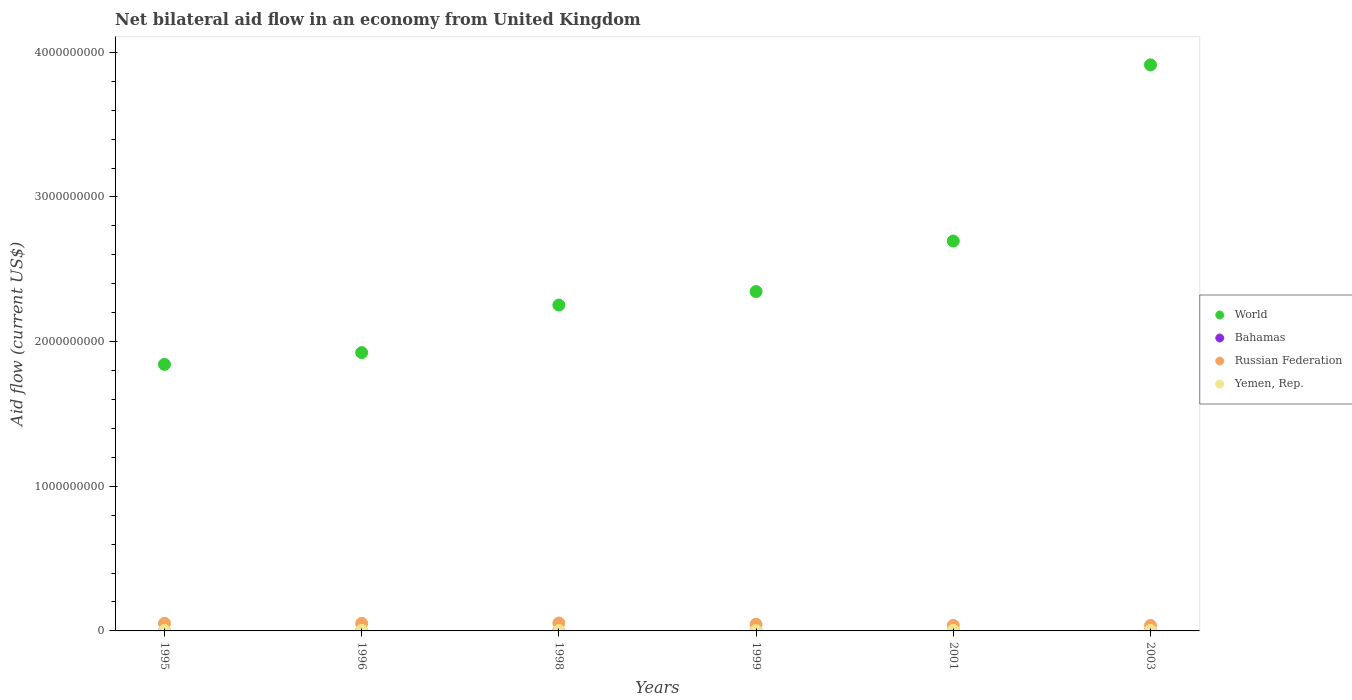How many different coloured dotlines are there?
Offer a very short reply. 4. What is the net bilateral aid flow in World in 1996?
Keep it short and to the point. 1.92e+09. Across all years, what is the maximum net bilateral aid flow in World?
Offer a terse response. 3.91e+09. Across all years, what is the minimum net bilateral aid flow in Yemen, Rep.?
Provide a short and direct response. 1.76e+06. In which year was the net bilateral aid flow in Russian Federation maximum?
Offer a terse response. 1998. In which year was the net bilateral aid flow in World minimum?
Provide a short and direct response. 1995. What is the total net bilateral aid flow in Yemen, Rep. in the graph?
Offer a terse response. 1.59e+07. What is the difference between the net bilateral aid flow in Russian Federation in 1996 and that in 1999?
Offer a very short reply. 5.66e+06. What is the difference between the net bilateral aid flow in Bahamas in 2003 and the net bilateral aid flow in Russian Federation in 1999?
Keep it short and to the point. -4.62e+07. What is the average net bilateral aid flow in Yemen, Rep. per year?
Offer a very short reply. 2.65e+06. In the year 1996, what is the difference between the net bilateral aid flow in World and net bilateral aid flow in Yemen, Rep.?
Offer a terse response. 1.92e+09. What is the ratio of the net bilateral aid flow in Yemen, Rep. in 1996 to that in 2003?
Your answer should be very brief. 1.17. What is the difference between the highest and the second highest net bilateral aid flow in World?
Offer a very short reply. 1.22e+09. In how many years, is the net bilateral aid flow in Yemen, Rep. greater than the average net bilateral aid flow in Yemen, Rep. taken over all years?
Your answer should be compact. 3. Is it the case that in every year, the sum of the net bilateral aid flow in Russian Federation and net bilateral aid flow in Yemen, Rep.  is greater than the sum of net bilateral aid flow in Bahamas and net bilateral aid flow in World?
Your answer should be very brief. Yes. Is it the case that in every year, the sum of the net bilateral aid flow in World and net bilateral aid flow in Bahamas  is greater than the net bilateral aid flow in Yemen, Rep.?
Ensure brevity in your answer.  Yes. Does the net bilateral aid flow in Yemen, Rep. monotonically increase over the years?
Your response must be concise. No. Is the net bilateral aid flow in Bahamas strictly less than the net bilateral aid flow in Russian Federation over the years?
Give a very brief answer. Yes. How many dotlines are there?
Provide a succinct answer. 4. Where does the legend appear in the graph?
Provide a short and direct response. Center right. How are the legend labels stacked?
Offer a terse response. Vertical. What is the title of the graph?
Give a very brief answer. Net bilateral aid flow in an economy from United Kingdom. What is the label or title of the Y-axis?
Make the answer very short. Aid flow (current US$). What is the Aid flow (current US$) of World in 1995?
Give a very brief answer. 1.84e+09. What is the Aid flow (current US$) of Bahamas in 1995?
Ensure brevity in your answer.  7.00e+04. What is the Aid flow (current US$) in Russian Federation in 1995?
Give a very brief answer. 5.23e+07. What is the Aid flow (current US$) in Yemen, Rep. in 1995?
Keep it short and to the point. 2.44e+06. What is the Aid flow (current US$) of World in 1996?
Ensure brevity in your answer.  1.92e+09. What is the Aid flow (current US$) of Russian Federation in 1996?
Make the answer very short. 5.18e+07. What is the Aid flow (current US$) of Yemen, Rep. in 1996?
Offer a terse response. 3.36e+06. What is the Aid flow (current US$) of World in 1998?
Give a very brief answer. 2.25e+09. What is the Aid flow (current US$) in Russian Federation in 1998?
Give a very brief answer. 5.48e+07. What is the Aid flow (current US$) in Yemen, Rep. in 1998?
Keep it short and to the point. 2.13e+06. What is the Aid flow (current US$) of World in 1999?
Your answer should be very brief. 2.35e+09. What is the Aid flow (current US$) of Bahamas in 1999?
Make the answer very short. 3.00e+04. What is the Aid flow (current US$) in Russian Federation in 1999?
Provide a short and direct response. 4.62e+07. What is the Aid flow (current US$) in Yemen, Rep. in 1999?
Offer a terse response. 1.76e+06. What is the Aid flow (current US$) in World in 2001?
Make the answer very short. 2.70e+09. What is the Aid flow (current US$) in Bahamas in 2001?
Your answer should be very brief. 4.00e+04. What is the Aid flow (current US$) of Russian Federation in 2001?
Give a very brief answer. 3.83e+07. What is the Aid flow (current US$) in Yemen, Rep. in 2001?
Offer a terse response. 3.33e+06. What is the Aid flow (current US$) of World in 2003?
Provide a short and direct response. 3.91e+09. What is the Aid flow (current US$) in Bahamas in 2003?
Your answer should be very brief. 2.00e+04. What is the Aid flow (current US$) in Russian Federation in 2003?
Offer a very short reply. 3.79e+07. What is the Aid flow (current US$) in Yemen, Rep. in 2003?
Provide a succinct answer. 2.87e+06. Across all years, what is the maximum Aid flow (current US$) of World?
Offer a very short reply. 3.91e+09. Across all years, what is the maximum Aid flow (current US$) in Bahamas?
Your response must be concise. 1.60e+05. Across all years, what is the maximum Aid flow (current US$) of Russian Federation?
Give a very brief answer. 5.48e+07. Across all years, what is the maximum Aid flow (current US$) in Yemen, Rep.?
Provide a short and direct response. 3.36e+06. Across all years, what is the minimum Aid flow (current US$) of World?
Give a very brief answer. 1.84e+09. Across all years, what is the minimum Aid flow (current US$) in Bahamas?
Give a very brief answer. 2.00e+04. Across all years, what is the minimum Aid flow (current US$) of Russian Federation?
Your answer should be compact. 3.79e+07. Across all years, what is the minimum Aid flow (current US$) of Yemen, Rep.?
Offer a terse response. 1.76e+06. What is the total Aid flow (current US$) of World in the graph?
Give a very brief answer. 1.50e+1. What is the total Aid flow (current US$) of Bahamas in the graph?
Offer a very short reply. 3.40e+05. What is the total Aid flow (current US$) of Russian Federation in the graph?
Offer a very short reply. 2.81e+08. What is the total Aid flow (current US$) of Yemen, Rep. in the graph?
Offer a terse response. 1.59e+07. What is the difference between the Aid flow (current US$) in World in 1995 and that in 1996?
Provide a short and direct response. -8.12e+07. What is the difference between the Aid flow (current US$) of Bahamas in 1995 and that in 1996?
Your answer should be very brief. -9.00e+04. What is the difference between the Aid flow (current US$) in Yemen, Rep. in 1995 and that in 1996?
Ensure brevity in your answer.  -9.20e+05. What is the difference between the Aid flow (current US$) in World in 1995 and that in 1998?
Your answer should be compact. -4.10e+08. What is the difference between the Aid flow (current US$) in Russian Federation in 1995 and that in 1998?
Provide a short and direct response. -2.48e+06. What is the difference between the Aid flow (current US$) of Yemen, Rep. in 1995 and that in 1998?
Your answer should be compact. 3.10e+05. What is the difference between the Aid flow (current US$) of World in 1995 and that in 1999?
Your response must be concise. -5.03e+08. What is the difference between the Aid flow (current US$) of Bahamas in 1995 and that in 1999?
Make the answer very short. 4.00e+04. What is the difference between the Aid flow (current US$) in Russian Federation in 1995 and that in 1999?
Offer a terse response. 6.14e+06. What is the difference between the Aid flow (current US$) of Yemen, Rep. in 1995 and that in 1999?
Your answer should be very brief. 6.80e+05. What is the difference between the Aid flow (current US$) in World in 1995 and that in 2001?
Provide a succinct answer. -8.53e+08. What is the difference between the Aid flow (current US$) in Russian Federation in 1995 and that in 2001?
Make the answer very short. 1.40e+07. What is the difference between the Aid flow (current US$) in Yemen, Rep. in 1995 and that in 2001?
Keep it short and to the point. -8.90e+05. What is the difference between the Aid flow (current US$) in World in 1995 and that in 2003?
Your response must be concise. -2.07e+09. What is the difference between the Aid flow (current US$) of Bahamas in 1995 and that in 2003?
Your answer should be compact. 5.00e+04. What is the difference between the Aid flow (current US$) of Russian Federation in 1995 and that in 2003?
Offer a terse response. 1.45e+07. What is the difference between the Aid flow (current US$) of Yemen, Rep. in 1995 and that in 2003?
Ensure brevity in your answer.  -4.30e+05. What is the difference between the Aid flow (current US$) of World in 1996 and that in 1998?
Provide a succinct answer. -3.29e+08. What is the difference between the Aid flow (current US$) of Bahamas in 1996 and that in 1998?
Provide a short and direct response. 1.40e+05. What is the difference between the Aid flow (current US$) in Russian Federation in 1996 and that in 1998?
Offer a very short reply. -2.96e+06. What is the difference between the Aid flow (current US$) in Yemen, Rep. in 1996 and that in 1998?
Offer a terse response. 1.23e+06. What is the difference between the Aid flow (current US$) in World in 1996 and that in 1999?
Offer a terse response. -4.22e+08. What is the difference between the Aid flow (current US$) in Russian Federation in 1996 and that in 1999?
Your answer should be very brief. 5.66e+06. What is the difference between the Aid flow (current US$) of Yemen, Rep. in 1996 and that in 1999?
Make the answer very short. 1.60e+06. What is the difference between the Aid flow (current US$) in World in 1996 and that in 2001?
Make the answer very short. -7.72e+08. What is the difference between the Aid flow (current US$) in Bahamas in 1996 and that in 2001?
Give a very brief answer. 1.20e+05. What is the difference between the Aid flow (current US$) in Russian Federation in 1996 and that in 2001?
Your answer should be very brief. 1.35e+07. What is the difference between the Aid flow (current US$) of Yemen, Rep. in 1996 and that in 2001?
Make the answer very short. 3.00e+04. What is the difference between the Aid flow (current US$) of World in 1996 and that in 2003?
Your response must be concise. -1.99e+09. What is the difference between the Aid flow (current US$) in Bahamas in 1996 and that in 2003?
Make the answer very short. 1.40e+05. What is the difference between the Aid flow (current US$) in Russian Federation in 1996 and that in 2003?
Provide a succinct answer. 1.40e+07. What is the difference between the Aid flow (current US$) in Yemen, Rep. in 1996 and that in 2003?
Offer a terse response. 4.90e+05. What is the difference between the Aid flow (current US$) in World in 1998 and that in 1999?
Offer a terse response. -9.33e+07. What is the difference between the Aid flow (current US$) of Bahamas in 1998 and that in 1999?
Offer a terse response. -10000. What is the difference between the Aid flow (current US$) of Russian Federation in 1998 and that in 1999?
Give a very brief answer. 8.62e+06. What is the difference between the Aid flow (current US$) in Yemen, Rep. in 1998 and that in 1999?
Make the answer very short. 3.70e+05. What is the difference between the Aid flow (current US$) in World in 1998 and that in 2001?
Provide a short and direct response. -4.43e+08. What is the difference between the Aid flow (current US$) of Bahamas in 1998 and that in 2001?
Offer a terse response. -2.00e+04. What is the difference between the Aid flow (current US$) of Russian Federation in 1998 and that in 2001?
Offer a very short reply. 1.65e+07. What is the difference between the Aid flow (current US$) in Yemen, Rep. in 1998 and that in 2001?
Provide a short and direct response. -1.20e+06. What is the difference between the Aid flow (current US$) in World in 1998 and that in 2003?
Keep it short and to the point. -1.66e+09. What is the difference between the Aid flow (current US$) of Bahamas in 1998 and that in 2003?
Your response must be concise. 0. What is the difference between the Aid flow (current US$) of Russian Federation in 1998 and that in 2003?
Offer a terse response. 1.69e+07. What is the difference between the Aid flow (current US$) in Yemen, Rep. in 1998 and that in 2003?
Ensure brevity in your answer.  -7.40e+05. What is the difference between the Aid flow (current US$) in World in 1999 and that in 2001?
Your response must be concise. -3.49e+08. What is the difference between the Aid flow (current US$) in Russian Federation in 1999 and that in 2001?
Offer a very short reply. 7.88e+06. What is the difference between the Aid flow (current US$) in Yemen, Rep. in 1999 and that in 2001?
Your response must be concise. -1.57e+06. What is the difference between the Aid flow (current US$) in World in 1999 and that in 2003?
Your answer should be very brief. -1.57e+09. What is the difference between the Aid flow (current US$) of Russian Federation in 1999 and that in 2003?
Your answer should be compact. 8.32e+06. What is the difference between the Aid flow (current US$) of Yemen, Rep. in 1999 and that in 2003?
Keep it short and to the point. -1.11e+06. What is the difference between the Aid flow (current US$) of World in 2001 and that in 2003?
Ensure brevity in your answer.  -1.22e+09. What is the difference between the Aid flow (current US$) of Yemen, Rep. in 2001 and that in 2003?
Ensure brevity in your answer.  4.60e+05. What is the difference between the Aid flow (current US$) of World in 1995 and the Aid flow (current US$) of Bahamas in 1996?
Ensure brevity in your answer.  1.84e+09. What is the difference between the Aid flow (current US$) of World in 1995 and the Aid flow (current US$) of Russian Federation in 1996?
Keep it short and to the point. 1.79e+09. What is the difference between the Aid flow (current US$) in World in 1995 and the Aid flow (current US$) in Yemen, Rep. in 1996?
Provide a short and direct response. 1.84e+09. What is the difference between the Aid flow (current US$) of Bahamas in 1995 and the Aid flow (current US$) of Russian Federation in 1996?
Provide a short and direct response. -5.18e+07. What is the difference between the Aid flow (current US$) in Bahamas in 1995 and the Aid flow (current US$) in Yemen, Rep. in 1996?
Your response must be concise. -3.29e+06. What is the difference between the Aid flow (current US$) of Russian Federation in 1995 and the Aid flow (current US$) of Yemen, Rep. in 1996?
Your answer should be very brief. 4.90e+07. What is the difference between the Aid flow (current US$) of World in 1995 and the Aid flow (current US$) of Bahamas in 1998?
Your answer should be compact. 1.84e+09. What is the difference between the Aid flow (current US$) of World in 1995 and the Aid flow (current US$) of Russian Federation in 1998?
Make the answer very short. 1.79e+09. What is the difference between the Aid flow (current US$) in World in 1995 and the Aid flow (current US$) in Yemen, Rep. in 1998?
Your answer should be very brief. 1.84e+09. What is the difference between the Aid flow (current US$) of Bahamas in 1995 and the Aid flow (current US$) of Russian Federation in 1998?
Ensure brevity in your answer.  -5.47e+07. What is the difference between the Aid flow (current US$) in Bahamas in 1995 and the Aid flow (current US$) in Yemen, Rep. in 1998?
Provide a short and direct response. -2.06e+06. What is the difference between the Aid flow (current US$) in Russian Federation in 1995 and the Aid flow (current US$) in Yemen, Rep. in 1998?
Your answer should be very brief. 5.02e+07. What is the difference between the Aid flow (current US$) in World in 1995 and the Aid flow (current US$) in Bahamas in 1999?
Keep it short and to the point. 1.84e+09. What is the difference between the Aid flow (current US$) in World in 1995 and the Aid flow (current US$) in Russian Federation in 1999?
Give a very brief answer. 1.80e+09. What is the difference between the Aid flow (current US$) of World in 1995 and the Aid flow (current US$) of Yemen, Rep. in 1999?
Your answer should be compact. 1.84e+09. What is the difference between the Aid flow (current US$) in Bahamas in 1995 and the Aid flow (current US$) in Russian Federation in 1999?
Provide a short and direct response. -4.61e+07. What is the difference between the Aid flow (current US$) of Bahamas in 1995 and the Aid flow (current US$) of Yemen, Rep. in 1999?
Provide a succinct answer. -1.69e+06. What is the difference between the Aid flow (current US$) in Russian Federation in 1995 and the Aid flow (current US$) in Yemen, Rep. in 1999?
Ensure brevity in your answer.  5.06e+07. What is the difference between the Aid flow (current US$) in World in 1995 and the Aid flow (current US$) in Bahamas in 2001?
Give a very brief answer. 1.84e+09. What is the difference between the Aid flow (current US$) of World in 1995 and the Aid flow (current US$) of Russian Federation in 2001?
Your response must be concise. 1.80e+09. What is the difference between the Aid flow (current US$) of World in 1995 and the Aid flow (current US$) of Yemen, Rep. in 2001?
Offer a very short reply. 1.84e+09. What is the difference between the Aid flow (current US$) of Bahamas in 1995 and the Aid flow (current US$) of Russian Federation in 2001?
Provide a short and direct response. -3.82e+07. What is the difference between the Aid flow (current US$) of Bahamas in 1995 and the Aid flow (current US$) of Yemen, Rep. in 2001?
Your response must be concise. -3.26e+06. What is the difference between the Aid flow (current US$) in Russian Federation in 1995 and the Aid flow (current US$) in Yemen, Rep. in 2001?
Offer a terse response. 4.90e+07. What is the difference between the Aid flow (current US$) of World in 1995 and the Aid flow (current US$) of Bahamas in 2003?
Your answer should be very brief. 1.84e+09. What is the difference between the Aid flow (current US$) in World in 1995 and the Aid flow (current US$) in Russian Federation in 2003?
Give a very brief answer. 1.80e+09. What is the difference between the Aid flow (current US$) of World in 1995 and the Aid flow (current US$) of Yemen, Rep. in 2003?
Provide a succinct answer. 1.84e+09. What is the difference between the Aid flow (current US$) in Bahamas in 1995 and the Aid flow (current US$) in Russian Federation in 2003?
Make the answer very short. -3.78e+07. What is the difference between the Aid flow (current US$) of Bahamas in 1995 and the Aid flow (current US$) of Yemen, Rep. in 2003?
Ensure brevity in your answer.  -2.80e+06. What is the difference between the Aid flow (current US$) in Russian Federation in 1995 and the Aid flow (current US$) in Yemen, Rep. in 2003?
Provide a succinct answer. 4.95e+07. What is the difference between the Aid flow (current US$) in World in 1996 and the Aid flow (current US$) in Bahamas in 1998?
Make the answer very short. 1.92e+09. What is the difference between the Aid flow (current US$) of World in 1996 and the Aid flow (current US$) of Russian Federation in 1998?
Provide a short and direct response. 1.87e+09. What is the difference between the Aid flow (current US$) of World in 1996 and the Aid flow (current US$) of Yemen, Rep. in 1998?
Keep it short and to the point. 1.92e+09. What is the difference between the Aid flow (current US$) of Bahamas in 1996 and the Aid flow (current US$) of Russian Federation in 1998?
Provide a short and direct response. -5.46e+07. What is the difference between the Aid flow (current US$) of Bahamas in 1996 and the Aid flow (current US$) of Yemen, Rep. in 1998?
Your response must be concise. -1.97e+06. What is the difference between the Aid flow (current US$) in Russian Federation in 1996 and the Aid flow (current US$) in Yemen, Rep. in 1998?
Offer a very short reply. 4.97e+07. What is the difference between the Aid flow (current US$) of World in 1996 and the Aid flow (current US$) of Bahamas in 1999?
Ensure brevity in your answer.  1.92e+09. What is the difference between the Aid flow (current US$) of World in 1996 and the Aid flow (current US$) of Russian Federation in 1999?
Offer a terse response. 1.88e+09. What is the difference between the Aid flow (current US$) in World in 1996 and the Aid flow (current US$) in Yemen, Rep. in 1999?
Give a very brief answer. 1.92e+09. What is the difference between the Aid flow (current US$) in Bahamas in 1996 and the Aid flow (current US$) in Russian Federation in 1999?
Offer a terse response. -4.60e+07. What is the difference between the Aid flow (current US$) of Bahamas in 1996 and the Aid flow (current US$) of Yemen, Rep. in 1999?
Keep it short and to the point. -1.60e+06. What is the difference between the Aid flow (current US$) in Russian Federation in 1996 and the Aid flow (current US$) in Yemen, Rep. in 1999?
Your answer should be very brief. 5.01e+07. What is the difference between the Aid flow (current US$) of World in 1996 and the Aid flow (current US$) of Bahamas in 2001?
Give a very brief answer. 1.92e+09. What is the difference between the Aid flow (current US$) of World in 1996 and the Aid flow (current US$) of Russian Federation in 2001?
Ensure brevity in your answer.  1.89e+09. What is the difference between the Aid flow (current US$) of World in 1996 and the Aid flow (current US$) of Yemen, Rep. in 2001?
Your response must be concise. 1.92e+09. What is the difference between the Aid flow (current US$) of Bahamas in 1996 and the Aid flow (current US$) of Russian Federation in 2001?
Provide a short and direct response. -3.82e+07. What is the difference between the Aid flow (current US$) in Bahamas in 1996 and the Aid flow (current US$) in Yemen, Rep. in 2001?
Offer a terse response. -3.17e+06. What is the difference between the Aid flow (current US$) of Russian Federation in 1996 and the Aid flow (current US$) of Yemen, Rep. in 2001?
Your answer should be very brief. 4.85e+07. What is the difference between the Aid flow (current US$) in World in 1996 and the Aid flow (current US$) in Bahamas in 2003?
Your answer should be compact. 1.92e+09. What is the difference between the Aid flow (current US$) in World in 1996 and the Aid flow (current US$) in Russian Federation in 2003?
Your answer should be very brief. 1.89e+09. What is the difference between the Aid flow (current US$) of World in 1996 and the Aid flow (current US$) of Yemen, Rep. in 2003?
Your answer should be very brief. 1.92e+09. What is the difference between the Aid flow (current US$) of Bahamas in 1996 and the Aid flow (current US$) of Russian Federation in 2003?
Make the answer very short. -3.77e+07. What is the difference between the Aid flow (current US$) of Bahamas in 1996 and the Aid flow (current US$) of Yemen, Rep. in 2003?
Keep it short and to the point. -2.71e+06. What is the difference between the Aid flow (current US$) of Russian Federation in 1996 and the Aid flow (current US$) of Yemen, Rep. in 2003?
Give a very brief answer. 4.90e+07. What is the difference between the Aid flow (current US$) of World in 1998 and the Aid flow (current US$) of Bahamas in 1999?
Ensure brevity in your answer.  2.25e+09. What is the difference between the Aid flow (current US$) of World in 1998 and the Aid flow (current US$) of Russian Federation in 1999?
Give a very brief answer. 2.21e+09. What is the difference between the Aid flow (current US$) in World in 1998 and the Aid flow (current US$) in Yemen, Rep. in 1999?
Offer a very short reply. 2.25e+09. What is the difference between the Aid flow (current US$) in Bahamas in 1998 and the Aid flow (current US$) in Russian Federation in 1999?
Offer a terse response. -4.62e+07. What is the difference between the Aid flow (current US$) of Bahamas in 1998 and the Aid flow (current US$) of Yemen, Rep. in 1999?
Provide a succinct answer. -1.74e+06. What is the difference between the Aid flow (current US$) in Russian Federation in 1998 and the Aid flow (current US$) in Yemen, Rep. in 1999?
Your answer should be very brief. 5.30e+07. What is the difference between the Aid flow (current US$) in World in 1998 and the Aid flow (current US$) in Bahamas in 2001?
Keep it short and to the point. 2.25e+09. What is the difference between the Aid flow (current US$) in World in 1998 and the Aid flow (current US$) in Russian Federation in 2001?
Offer a terse response. 2.21e+09. What is the difference between the Aid flow (current US$) of World in 1998 and the Aid flow (current US$) of Yemen, Rep. in 2001?
Offer a very short reply. 2.25e+09. What is the difference between the Aid flow (current US$) of Bahamas in 1998 and the Aid flow (current US$) of Russian Federation in 2001?
Ensure brevity in your answer.  -3.83e+07. What is the difference between the Aid flow (current US$) of Bahamas in 1998 and the Aid flow (current US$) of Yemen, Rep. in 2001?
Give a very brief answer. -3.31e+06. What is the difference between the Aid flow (current US$) of Russian Federation in 1998 and the Aid flow (current US$) of Yemen, Rep. in 2001?
Keep it short and to the point. 5.15e+07. What is the difference between the Aid flow (current US$) in World in 1998 and the Aid flow (current US$) in Bahamas in 2003?
Provide a short and direct response. 2.25e+09. What is the difference between the Aid flow (current US$) of World in 1998 and the Aid flow (current US$) of Russian Federation in 2003?
Provide a succinct answer. 2.22e+09. What is the difference between the Aid flow (current US$) in World in 1998 and the Aid flow (current US$) in Yemen, Rep. in 2003?
Give a very brief answer. 2.25e+09. What is the difference between the Aid flow (current US$) in Bahamas in 1998 and the Aid flow (current US$) in Russian Federation in 2003?
Offer a very short reply. -3.78e+07. What is the difference between the Aid flow (current US$) in Bahamas in 1998 and the Aid flow (current US$) in Yemen, Rep. in 2003?
Your answer should be very brief. -2.85e+06. What is the difference between the Aid flow (current US$) in Russian Federation in 1998 and the Aid flow (current US$) in Yemen, Rep. in 2003?
Your answer should be very brief. 5.19e+07. What is the difference between the Aid flow (current US$) of World in 1999 and the Aid flow (current US$) of Bahamas in 2001?
Your answer should be compact. 2.35e+09. What is the difference between the Aid flow (current US$) of World in 1999 and the Aid flow (current US$) of Russian Federation in 2001?
Keep it short and to the point. 2.31e+09. What is the difference between the Aid flow (current US$) of World in 1999 and the Aid flow (current US$) of Yemen, Rep. in 2001?
Your response must be concise. 2.34e+09. What is the difference between the Aid flow (current US$) in Bahamas in 1999 and the Aid flow (current US$) in Russian Federation in 2001?
Ensure brevity in your answer.  -3.83e+07. What is the difference between the Aid flow (current US$) in Bahamas in 1999 and the Aid flow (current US$) in Yemen, Rep. in 2001?
Your answer should be very brief. -3.30e+06. What is the difference between the Aid flow (current US$) of Russian Federation in 1999 and the Aid flow (current US$) of Yemen, Rep. in 2001?
Offer a very short reply. 4.29e+07. What is the difference between the Aid flow (current US$) of World in 1999 and the Aid flow (current US$) of Bahamas in 2003?
Make the answer very short. 2.35e+09. What is the difference between the Aid flow (current US$) in World in 1999 and the Aid flow (current US$) in Russian Federation in 2003?
Make the answer very short. 2.31e+09. What is the difference between the Aid flow (current US$) in World in 1999 and the Aid flow (current US$) in Yemen, Rep. in 2003?
Offer a terse response. 2.34e+09. What is the difference between the Aid flow (current US$) in Bahamas in 1999 and the Aid flow (current US$) in Russian Federation in 2003?
Your answer should be compact. -3.78e+07. What is the difference between the Aid flow (current US$) in Bahamas in 1999 and the Aid flow (current US$) in Yemen, Rep. in 2003?
Your answer should be compact. -2.84e+06. What is the difference between the Aid flow (current US$) in Russian Federation in 1999 and the Aid flow (current US$) in Yemen, Rep. in 2003?
Provide a succinct answer. 4.33e+07. What is the difference between the Aid flow (current US$) of World in 2001 and the Aid flow (current US$) of Bahamas in 2003?
Give a very brief answer. 2.70e+09. What is the difference between the Aid flow (current US$) of World in 2001 and the Aid flow (current US$) of Russian Federation in 2003?
Your response must be concise. 2.66e+09. What is the difference between the Aid flow (current US$) of World in 2001 and the Aid flow (current US$) of Yemen, Rep. in 2003?
Give a very brief answer. 2.69e+09. What is the difference between the Aid flow (current US$) of Bahamas in 2001 and the Aid flow (current US$) of Russian Federation in 2003?
Your response must be concise. -3.78e+07. What is the difference between the Aid flow (current US$) of Bahamas in 2001 and the Aid flow (current US$) of Yemen, Rep. in 2003?
Your answer should be very brief. -2.83e+06. What is the difference between the Aid flow (current US$) in Russian Federation in 2001 and the Aid flow (current US$) in Yemen, Rep. in 2003?
Provide a succinct answer. 3.54e+07. What is the average Aid flow (current US$) of World per year?
Provide a short and direct response. 2.50e+09. What is the average Aid flow (current US$) in Bahamas per year?
Provide a short and direct response. 5.67e+04. What is the average Aid flow (current US$) of Russian Federation per year?
Your answer should be very brief. 4.69e+07. What is the average Aid flow (current US$) of Yemen, Rep. per year?
Your response must be concise. 2.65e+06. In the year 1995, what is the difference between the Aid flow (current US$) of World and Aid flow (current US$) of Bahamas?
Give a very brief answer. 1.84e+09. In the year 1995, what is the difference between the Aid flow (current US$) of World and Aid flow (current US$) of Russian Federation?
Your answer should be compact. 1.79e+09. In the year 1995, what is the difference between the Aid flow (current US$) of World and Aid flow (current US$) of Yemen, Rep.?
Ensure brevity in your answer.  1.84e+09. In the year 1995, what is the difference between the Aid flow (current US$) of Bahamas and Aid flow (current US$) of Russian Federation?
Provide a succinct answer. -5.23e+07. In the year 1995, what is the difference between the Aid flow (current US$) of Bahamas and Aid flow (current US$) of Yemen, Rep.?
Your answer should be compact. -2.37e+06. In the year 1995, what is the difference between the Aid flow (current US$) of Russian Federation and Aid flow (current US$) of Yemen, Rep.?
Provide a short and direct response. 4.99e+07. In the year 1996, what is the difference between the Aid flow (current US$) of World and Aid flow (current US$) of Bahamas?
Make the answer very short. 1.92e+09. In the year 1996, what is the difference between the Aid flow (current US$) of World and Aid flow (current US$) of Russian Federation?
Your answer should be compact. 1.87e+09. In the year 1996, what is the difference between the Aid flow (current US$) of World and Aid flow (current US$) of Yemen, Rep.?
Provide a short and direct response. 1.92e+09. In the year 1996, what is the difference between the Aid flow (current US$) of Bahamas and Aid flow (current US$) of Russian Federation?
Your response must be concise. -5.17e+07. In the year 1996, what is the difference between the Aid flow (current US$) of Bahamas and Aid flow (current US$) of Yemen, Rep.?
Provide a succinct answer. -3.20e+06. In the year 1996, what is the difference between the Aid flow (current US$) of Russian Federation and Aid flow (current US$) of Yemen, Rep.?
Keep it short and to the point. 4.85e+07. In the year 1998, what is the difference between the Aid flow (current US$) in World and Aid flow (current US$) in Bahamas?
Your answer should be very brief. 2.25e+09. In the year 1998, what is the difference between the Aid flow (current US$) of World and Aid flow (current US$) of Russian Federation?
Make the answer very short. 2.20e+09. In the year 1998, what is the difference between the Aid flow (current US$) in World and Aid flow (current US$) in Yemen, Rep.?
Offer a very short reply. 2.25e+09. In the year 1998, what is the difference between the Aid flow (current US$) of Bahamas and Aid flow (current US$) of Russian Federation?
Your response must be concise. -5.48e+07. In the year 1998, what is the difference between the Aid flow (current US$) of Bahamas and Aid flow (current US$) of Yemen, Rep.?
Provide a succinct answer. -2.11e+06. In the year 1998, what is the difference between the Aid flow (current US$) of Russian Federation and Aid flow (current US$) of Yemen, Rep.?
Keep it short and to the point. 5.27e+07. In the year 1999, what is the difference between the Aid flow (current US$) in World and Aid flow (current US$) in Bahamas?
Offer a very short reply. 2.35e+09. In the year 1999, what is the difference between the Aid flow (current US$) of World and Aid flow (current US$) of Russian Federation?
Offer a terse response. 2.30e+09. In the year 1999, what is the difference between the Aid flow (current US$) of World and Aid flow (current US$) of Yemen, Rep.?
Ensure brevity in your answer.  2.34e+09. In the year 1999, what is the difference between the Aid flow (current US$) in Bahamas and Aid flow (current US$) in Russian Federation?
Provide a short and direct response. -4.62e+07. In the year 1999, what is the difference between the Aid flow (current US$) in Bahamas and Aid flow (current US$) in Yemen, Rep.?
Give a very brief answer. -1.73e+06. In the year 1999, what is the difference between the Aid flow (current US$) of Russian Federation and Aid flow (current US$) of Yemen, Rep.?
Keep it short and to the point. 4.44e+07. In the year 2001, what is the difference between the Aid flow (current US$) in World and Aid flow (current US$) in Bahamas?
Ensure brevity in your answer.  2.70e+09. In the year 2001, what is the difference between the Aid flow (current US$) in World and Aid flow (current US$) in Russian Federation?
Ensure brevity in your answer.  2.66e+09. In the year 2001, what is the difference between the Aid flow (current US$) of World and Aid flow (current US$) of Yemen, Rep.?
Offer a very short reply. 2.69e+09. In the year 2001, what is the difference between the Aid flow (current US$) in Bahamas and Aid flow (current US$) in Russian Federation?
Ensure brevity in your answer.  -3.83e+07. In the year 2001, what is the difference between the Aid flow (current US$) of Bahamas and Aid flow (current US$) of Yemen, Rep.?
Keep it short and to the point. -3.29e+06. In the year 2001, what is the difference between the Aid flow (current US$) of Russian Federation and Aid flow (current US$) of Yemen, Rep.?
Your response must be concise. 3.50e+07. In the year 2003, what is the difference between the Aid flow (current US$) of World and Aid flow (current US$) of Bahamas?
Make the answer very short. 3.91e+09. In the year 2003, what is the difference between the Aid flow (current US$) in World and Aid flow (current US$) in Russian Federation?
Provide a short and direct response. 3.88e+09. In the year 2003, what is the difference between the Aid flow (current US$) in World and Aid flow (current US$) in Yemen, Rep.?
Make the answer very short. 3.91e+09. In the year 2003, what is the difference between the Aid flow (current US$) of Bahamas and Aid flow (current US$) of Russian Federation?
Your answer should be compact. -3.78e+07. In the year 2003, what is the difference between the Aid flow (current US$) in Bahamas and Aid flow (current US$) in Yemen, Rep.?
Make the answer very short. -2.85e+06. In the year 2003, what is the difference between the Aid flow (current US$) of Russian Federation and Aid flow (current US$) of Yemen, Rep.?
Your answer should be compact. 3.50e+07. What is the ratio of the Aid flow (current US$) of World in 1995 to that in 1996?
Offer a terse response. 0.96. What is the ratio of the Aid flow (current US$) in Bahamas in 1995 to that in 1996?
Give a very brief answer. 0.44. What is the ratio of the Aid flow (current US$) in Russian Federation in 1995 to that in 1996?
Offer a very short reply. 1.01. What is the ratio of the Aid flow (current US$) in Yemen, Rep. in 1995 to that in 1996?
Provide a short and direct response. 0.73. What is the ratio of the Aid flow (current US$) of World in 1995 to that in 1998?
Offer a terse response. 0.82. What is the ratio of the Aid flow (current US$) in Bahamas in 1995 to that in 1998?
Make the answer very short. 3.5. What is the ratio of the Aid flow (current US$) of Russian Federation in 1995 to that in 1998?
Offer a terse response. 0.95. What is the ratio of the Aid flow (current US$) in Yemen, Rep. in 1995 to that in 1998?
Your answer should be very brief. 1.15. What is the ratio of the Aid flow (current US$) in World in 1995 to that in 1999?
Provide a succinct answer. 0.79. What is the ratio of the Aid flow (current US$) of Bahamas in 1995 to that in 1999?
Your answer should be very brief. 2.33. What is the ratio of the Aid flow (current US$) in Russian Federation in 1995 to that in 1999?
Your answer should be very brief. 1.13. What is the ratio of the Aid flow (current US$) in Yemen, Rep. in 1995 to that in 1999?
Your answer should be very brief. 1.39. What is the ratio of the Aid flow (current US$) in World in 1995 to that in 2001?
Ensure brevity in your answer.  0.68. What is the ratio of the Aid flow (current US$) in Bahamas in 1995 to that in 2001?
Keep it short and to the point. 1.75. What is the ratio of the Aid flow (current US$) of Russian Federation in 1995 to that in 2001?
Provide a short and direct response. 1.37. What is the ratio of the Aid flow (current US$) of Yemen, Rep. in 1995 to that in 2001?
Ensure brevity in your answer.  0.73. What is the ratio of the Aid flow (current US$) of World in 1995 to that in 2003?
Keep it short and to the point. 0.47. What is the ratio of the Aid flow (current US$) in Bahamas in 1995 to that in 2003?
Provide a short and direct response. 3.5. What is the ratio of the Aid flow (current US$) of Russian Federation in 1995 to that in 2003?
Offer a terse response. 1.38. What is the ratio of the Aid flow (current US$) of Yemen, Rep. in 1995 to that in 2003?
Offer a terse response. 0.85. What is the ratio of the Aid flow (current US$) of World in 1996 to that in 1998?
Your answer should be compact. 0.85. What is the ratio of the Aid flow (current US$) in Russian Federation in 1996 to that in 1998?
Keep it short and to the point. 0.95. What is the ratio of the Aid flow (current US$) in Yemen, Rep. in 1996 to that in 1998?
Provide a short and direct response. 1.58. What is the ratio of the Aid flow (current US$) in World in 1996 to that in 1999?
Your response must be concise. 0.82. What is the ratio of the Aid flow (current US$) of Bahamas in 1996 to that in 1999?
Give a very brief answer. 5.33. What is the ratio of the Aid flow (current US$) in Russian Federation in 1996 to that in 1999?
Your answer should be compact. 1.12. What is the ratio of the Aid flow (current US$) of Yemen, Rep. in 1996 to that in 1999?
Give a very brief answer. 1.91. What is the ratio of the Aid flow (current US$) in World in 1996 to that in 2001?
Your answer should be very brief. 0.71. What is the ratio of the Aid flow (current US$) in Russian Federation in 1996 to that in 2001?
Your answer should be compact. 1.35. What is the ratio of the Aid flow (current US$) of Yemen, Rep. in 1996 to that in 2001?
Provide a short and direct response. 1.01. What is the ratio of the Aid flow (current US$) of World in 1996 to that in 2003?
Ensure brevity in your answer.  0.49. What is the ratio of the Aid flow (current US$) in Russian Federation in 1996 to that in 2003?
Provide a succinct answer. 1.37. What is the ratio of the Aid flow (current US$) of Yemen, Rep. in 1996 to that in 2003?
Offer a very short reply. 1.17. What is the ratio of the Aid flow (current US$) in World in 1998 to that in 1999?
Your answer should be compact. 0.96. What is the ratio of the Aid flow (current US$) in Bahamas in 1998 to that in 1999?
Your answer should be compact. 0.67. What is the ratio of the Aid flow (current US$) of Russian Federation in 1998 to that in 1999?
Your answer should be very brief. 1.19. What is the ratio of the Aid flow (current US$) in Yemen, Rep. in 1998 to that in 1999?
Provide a short and direct response. 1.21. What is the ratio of the Aid flow (current US$) of World in 1998 to that in 2001?
Provide a succinct answer. 0.84. What is the ratio of the Aid flow (current US$) in Bahamas in 1998 to that in 2001?
Keep it short and to the point. 0.5. What is the ratio of the Aid flow (current US$) of Russian Federation in 1998 to that in 2001?
Provide a short and direct response. 1.43. What is the ratio of the Aid flow (current US$) in Yemen, Rep. in 1998 to that in 2001?
Ensure brevity in your answer.  0.64. What is the ratio of the Aid flow (current US$) of World in 1998 to that in 2003?
Provide a succinct answer. 0.58. What is the ratio of the Aid flow (current US$) of Russian Federation in 1998 to that in 2003?
Offer a terse response. 1.45. What is the ratio of the Aid flow (current US$) of Yemen, Rep. in 1998 to that in 2003?
Offer a terse response. 0.74. What is the ratio of the Aid flow (current US$) in World in 1999 to that in 2001?
Give a very brief answer. 0.87. What is the ratio of the Aid flow (current US$) of Russian Federation in 1999 to that in 2001?
Your answer should be compact. 1.21. What is the ratio of the Aid flow (current US$) in Yemen, Rep. in 1999 to that in 2001?
Provide a short and direct response. 0.53. What is the ratio of the Aid flow (current US$) of World in 1999 to that in 2003?
Offer a very short reply. 0.6. What is the ratio of the Aid flow (current US$) in Bahamas in 1999 to that in 2003?
Provide a succinct answer. 1.5. What is the ratio of the Aid flow (current US$) of Russian Federation in 1999 to that in 2003?
Your answer should be compact. 1.22. What is the ratio of the Aid flow (current US$) in Yemen, Rep. in 1999 to that in 2003?
Provide a succinct answer. 0.61. What is the ratio of the Aid flow (current US$) in World in 2001 to that in 2003?
Make the answer very short. 0.69. What is the ratio of the Aid flow (current US$) in Bahamas in 2001 to that in 2003?
Provide a short and direct response. 2. What is the ratio of the Aid flow (current US$) of Russian Federation in 2001 to that in 2003?
Provide a succinct answer. 1.01. What is the ratio of the Aid flow (current US$) in Yemen, Rep. in 2001 to that in 2003?
Your answer should be very brief. 1.16. What is the difference between the highest and the second highest Aid flow (current US$) in World?
Make the answer very short. 1.22e+09. What is the difference between the highest and the second highest Aid flow (current US$) of Bahamas?
Your answer should be very brief. 9.00e+04. What is the difference between the highest and the second highest Aid flow (current US$) of Russian Federation?
Offer a terse response. 2.48e+06. What is the difference between the highest and the second highest Aid flow (current US$) of Yemen, Rep.?
Ensure brevity in your answer.  3.00e+04. What is the difference between the highest and the lowest Aid flow (current US$) in World?
Keep it short and to the point. 2.07e+09. What is the difference between the highest and the lowest Aid flow (current US$) of Russian Federation?
Your response must be concise. 1.69e+07. What is the difference between the highest and the lowest Aid flow (current US$) of Yemen, Rep.?
Provide a succinct answer. 1.60e+06. 